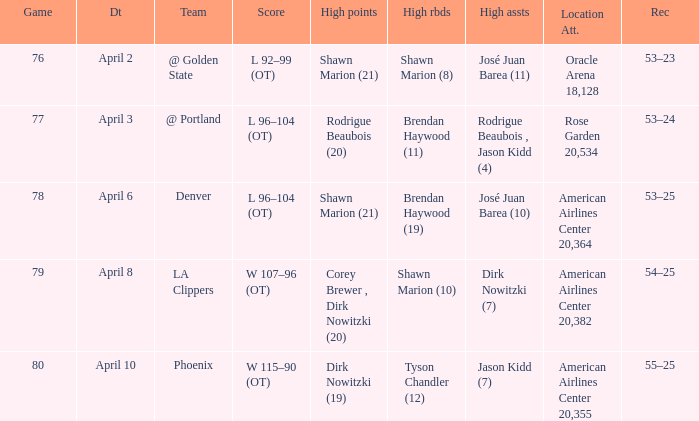What is the record after the Phoenix game? 55–25. 